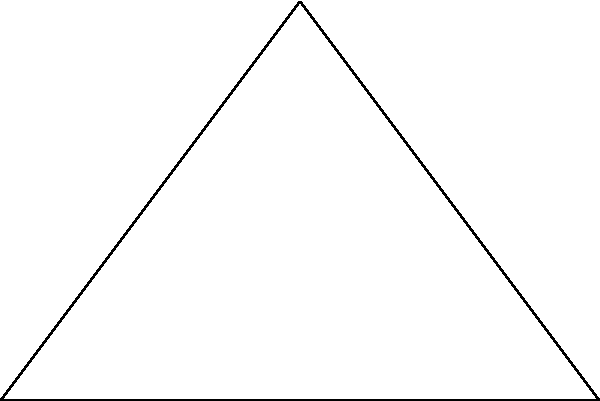For the new community garden project in Strabane, you've been allocated a triangular plot of land. The plot has a base of 6 meters and a height of 4 meters. What is the area of this triangular plot in square meters? To find the area of a triangular plot, we can use the formula:

Area = $\frac{1}{2} \times base \times height$

Given:
- Base of the triangle = 6 meters
- Height of the triangle = 4 meters

Let's calculate:

Area = $\frac{1}{2} \times 6 \times 4$
     = $\frac{1}{2} \times 24$
     = 12

Therefore, the area of the triangular plot is 12 square meters.
Answer: 12 m² 